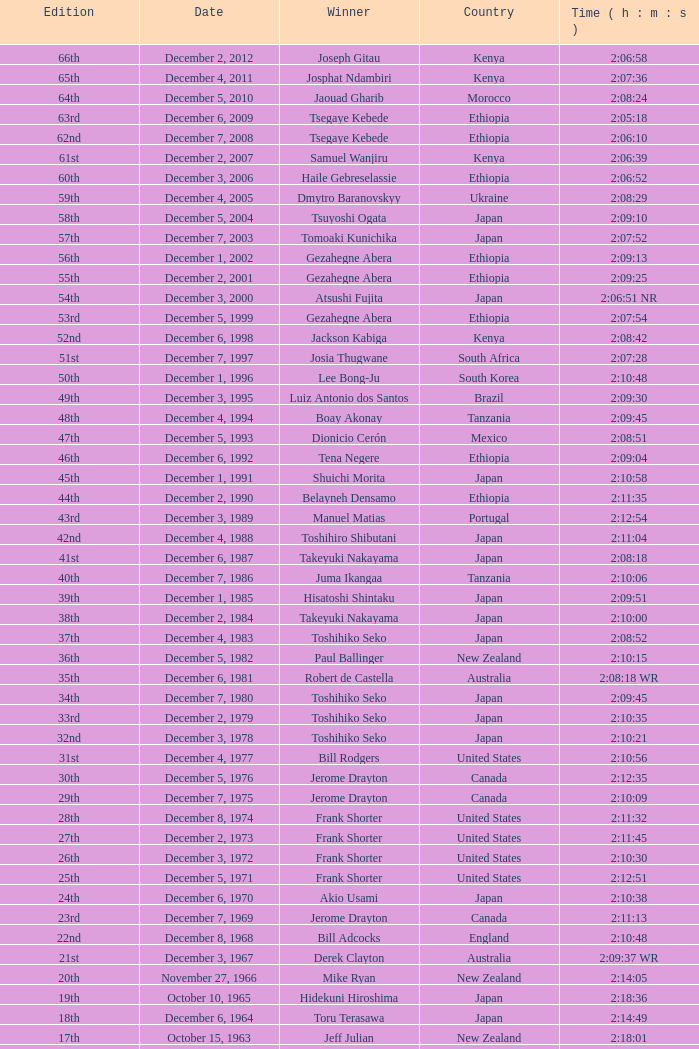Who was the winner of the 23rd Edition? Jerome Drayton. 